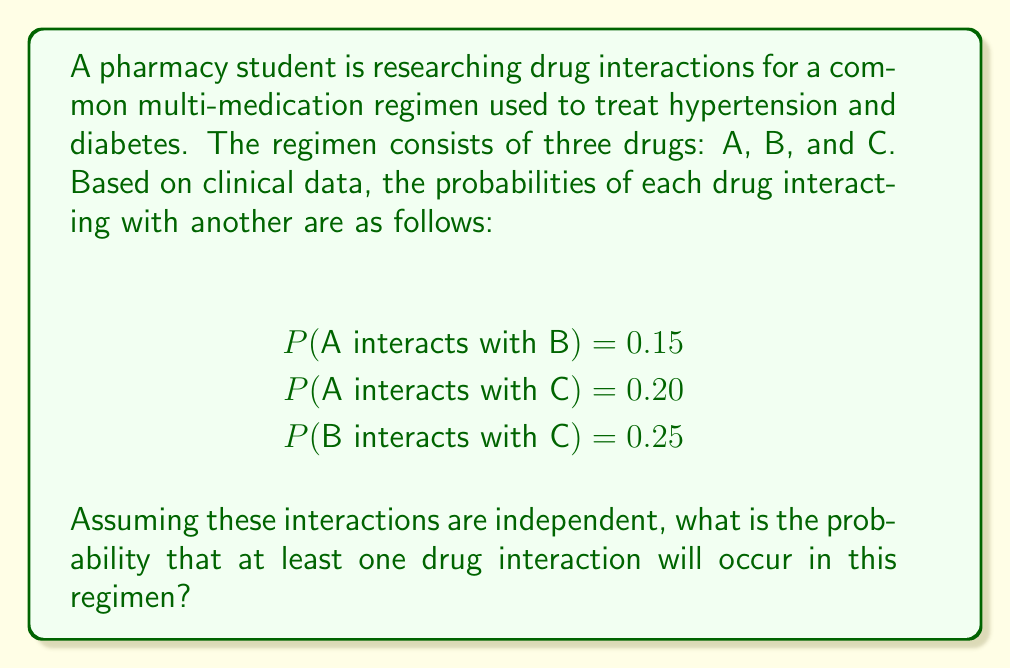What is the answer to this math problem? To solve this problem, we'll use the concept of joint probability distributions and the complement rule.

Step 1: First, let's calculate the probability that no interactions occur.

P(no interactions) = P(A doesn't interact with B) × P(A doesn't interact with C) × P(B doesn't interact with C)

Step 2: Convert the given probabilities to their complements:

P(A doesn't interact with B) = 1 - 0.15 = 0.85
P(A doesn't interact with C) = 1 - 0.20 = 0.80
P(B doesn't interact with C) = 1 - 0.25 = 0.75

Step 3: Multiply these probabilities:

P(no interactions) = 0.85 × 0.80 × 0.75 = 0.51

Step 4: Use the complement rule to find the probability of at least one interaction:

P(at least one interaction) = 1 - P(no interactions)
                            = 1 - 0.51
                            = 0.49

Therefore, the probability that at least one drug interaction will occur in this regimen is 0.49 or 49%.
Answer: 0.49 